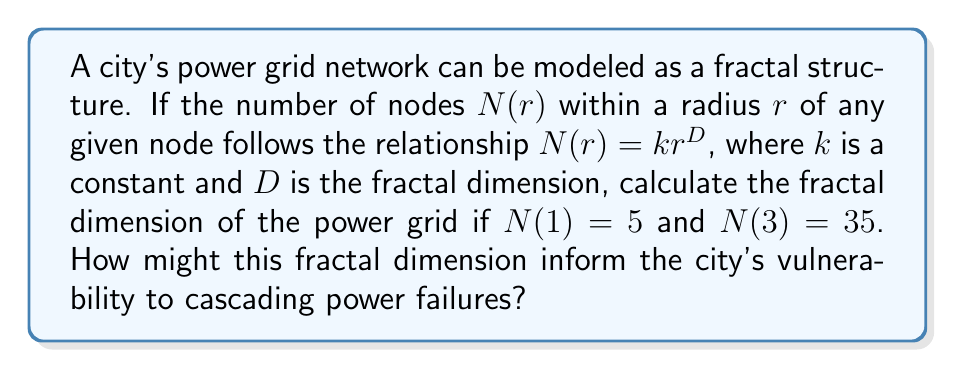Could you help me with this problem? To solve this problem, we'll use the given information to calculate the fractal dimension $D$. Then we'll interpret its significance for the city's power grid vulnerability.

Step 1: Set up the equations using the given information.
For $r = 1$: $N(1) = k(1)^D = k = 5$
For $r = 3$: $N(3) = k(3)^D = 35$

Step 2: Substitute $k = 5$ into the equation for $r = 3$.
$5(3)^D = 35$

Step 3: Solve for $D$ using logarithms.
$$(3)^D = \frac{35}{5} = 7$$
$$D \log(3) = \log(7)$$
$$D = \frac{\log(7)}{\log(3)} \approx 1.7712$$

Step 4: Interpret the result.
The fractal dimension $D \approx 1.7712$ indicates that the power grid has a structure more complex than a simple line ($D = 1$) but less space-filling than a plane ($D = 2$). This suggests:

1. The network has a moderate degree of redundancy and interconnectedness.
2. It may be somewhat resilient to random failures, as alternative paths exist.
3. However, it's also vulnerable to targeted attacks or cascading failures, especially at critical nodes.

A higher fractal dimension (closer to 2) would indicate a more interconnected and potentially more resilient network, while a lower dimension (closer to 1) would suggest a more linear, vulnerable structure.
Answer: $D \approx 1.7712$; moderate redundancy, some resilience to random failures, vulnerable to targeted attacks. 